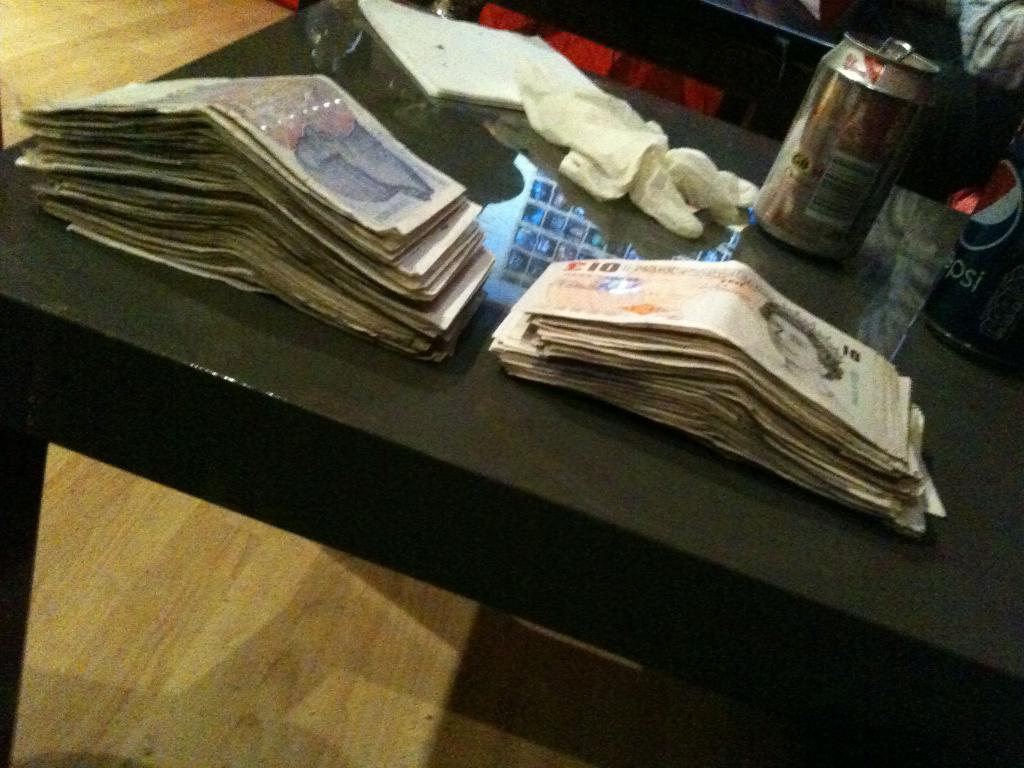What type of items can be seen in the image? There are currency notes in the image. Can you describe the denominations of the currency notes? There are tens (possibly referring to denominations) in the image. What color are the objects in the image? There are white color objects in the image. What is the color of the table in the image? The table in the image is black in color. How many pigs are visible in the image? There are no pigs present in the image. Is there a person sitting at the table in the image? The image does not show a person sitting at the table. 